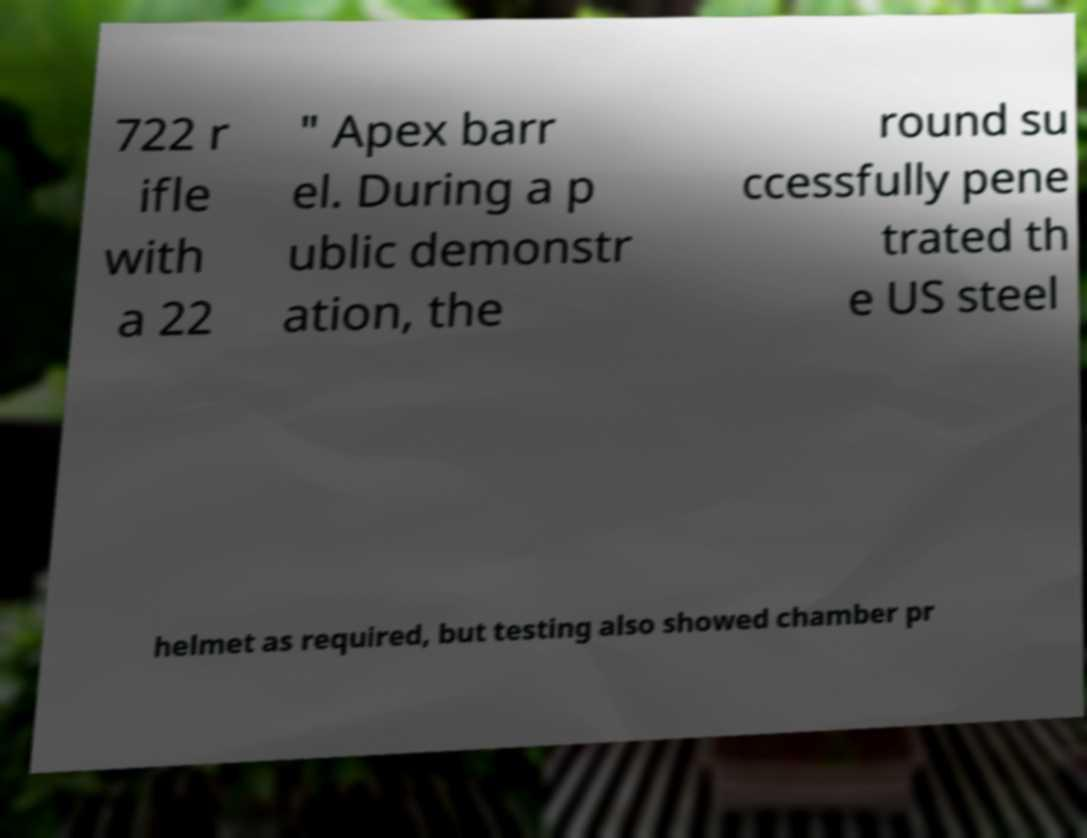Could you extract and type out the text from this image? 722 r ifle with a 22 " Apex barr el. During a p ublic demonstr ation, the round su ccessfully pene trated th e US steel helmet as required, but testing also showed chamber pr 